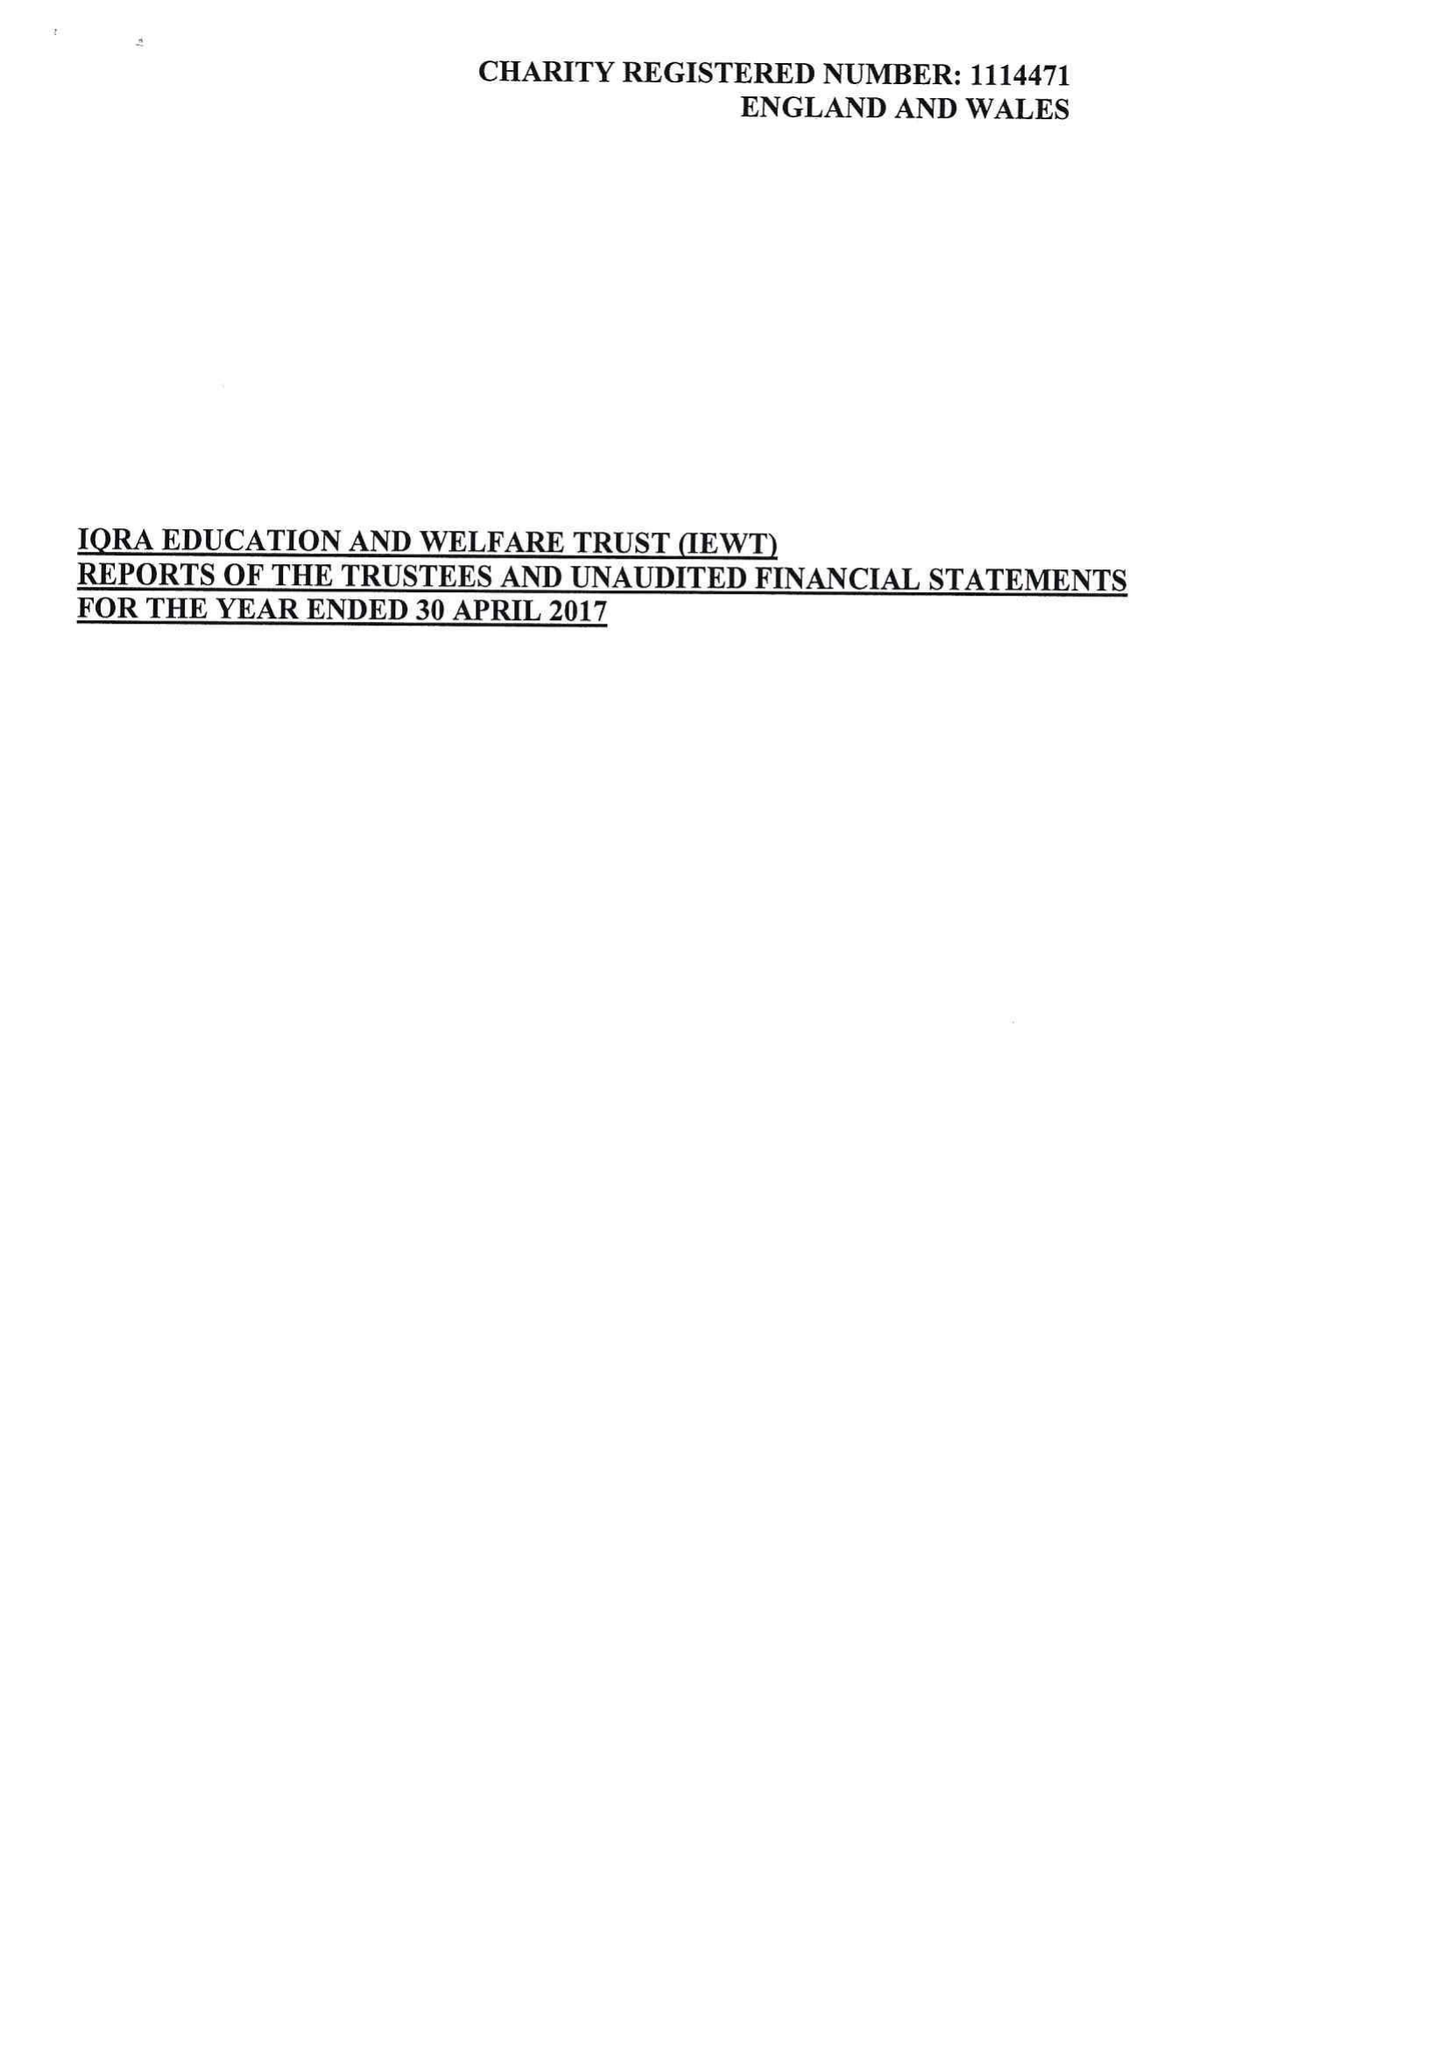What is the value for the address__post_town?
Answer the question using a single word or phrase. OLDHAM 